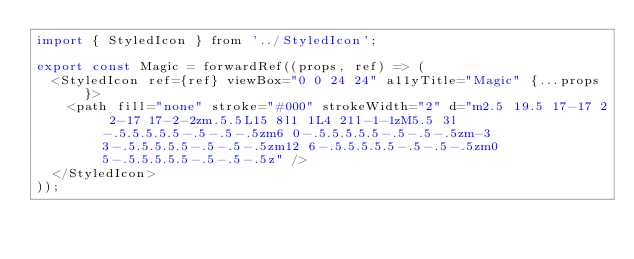<code> <loc_0><loc_0><loc_500><loc_500><_JavaScript_>import { StyledIcon } from '../StyledIcon';

export const Magic = forwardRef((props, ref) => (
  <StyledIcon ref={ref} viewBox="0 0 24 24" a11yTitle="Magic" {...props}>
    <path fill="none" stroke="#000" strokeWidth="2" d="m2.5 19.5 17-17 2 2-17 17-2-2zm.5.5L15 8l1 1L4 21l-1-1zM5.5 3l-.5.5.5.5.5-.5-.5-.5zm6 0-.5.5.5.5.5-.5-.5-.5zm-3 3-.5.5.5.5.5-.5-.5-.5zm12 6-.5.5.5.5.5-.5-.5-.5zm0 5-.5.5.5.5.5-.5-.5-.5z" />
  </StyledIcon>
));
</code> 